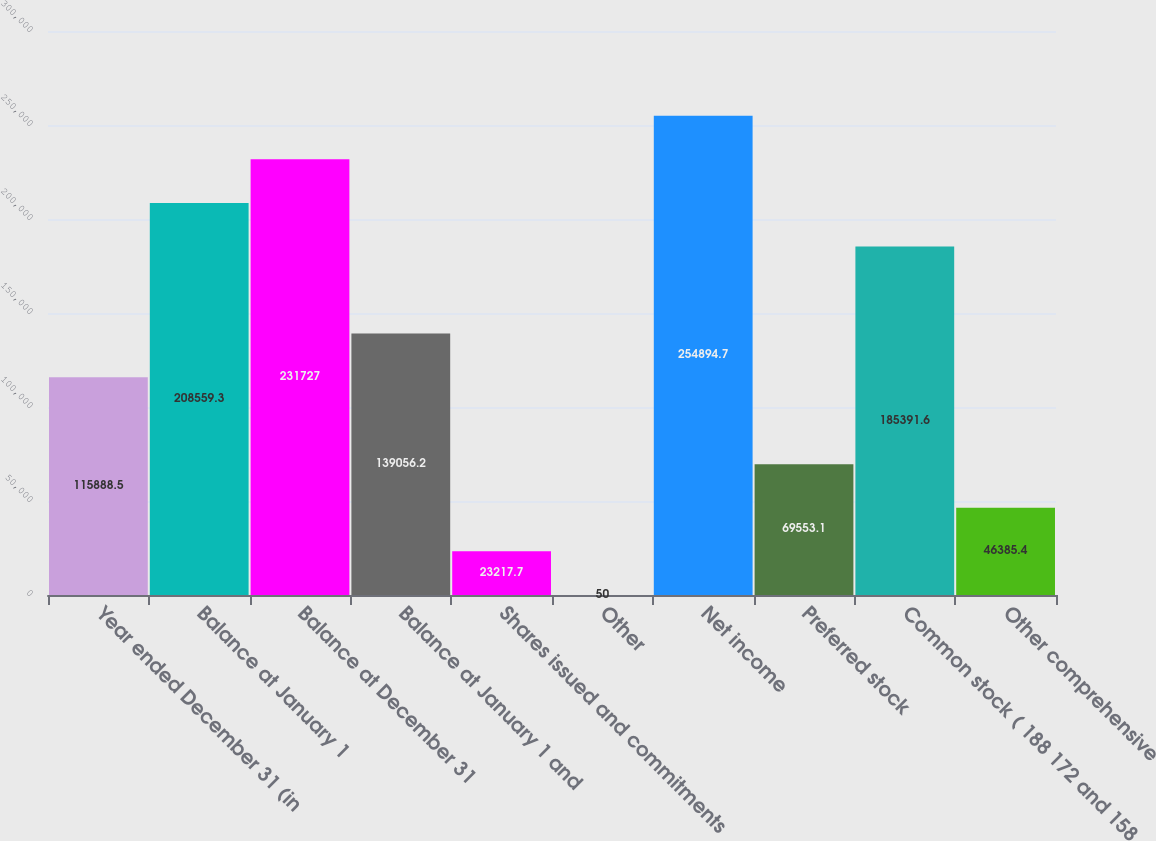<chart> <loc_0><loc_0><loc_500><loc_500><bar_chart><fcel>Year ended December 31 (in<fcel>Balance at January 1<fcel>Balance at December 31<fcel>Balance at January 1 and<fcel>Shares issued and commitments<fcel>Other<fcel>Net income<fcel>Preferred stock<fcel>Common stock ( 188 172 and 158<fcel>Other comprehensive<nl><fcel>115888<fcel>208559<fcel>231727<fcel>139056<fcel>23217.7<fcel>50<fcel>254895<fcel>69553.1<fcel>185392<fcel>46385.4<nl></chart> 